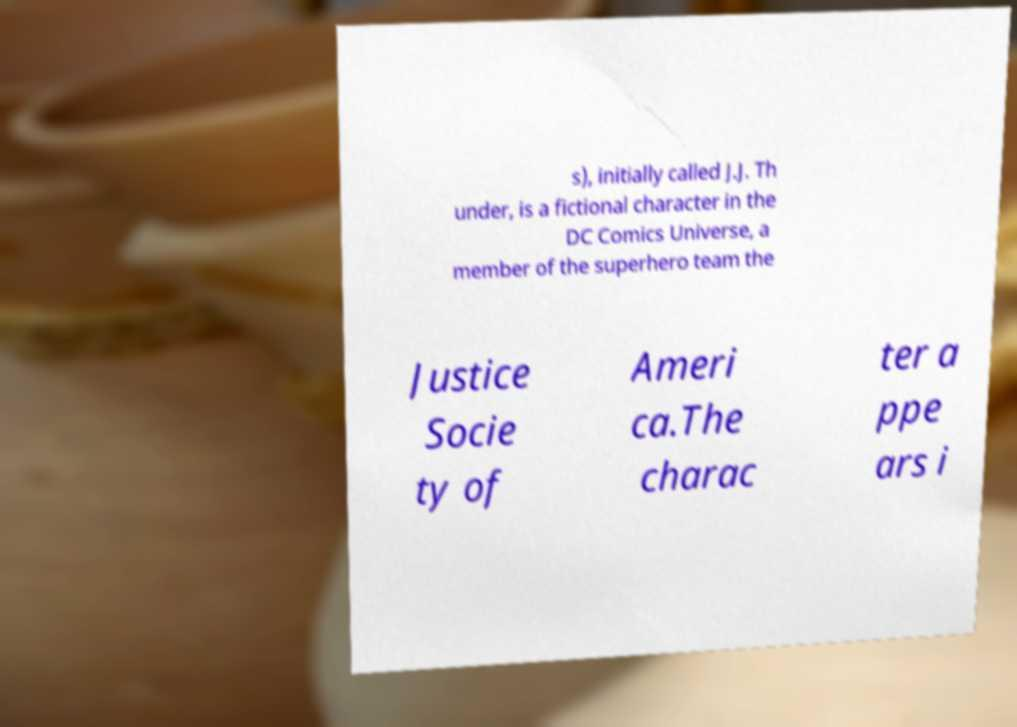There's text embedded in this image that I need extracted. Can you transcribe it verbatim? s), initially called J.J. Th under, is a fictional character in the DC Comics Universe, a member of the superhero team the Justice Socie ty of Ameri ca.The charac ter a ppe ars i 